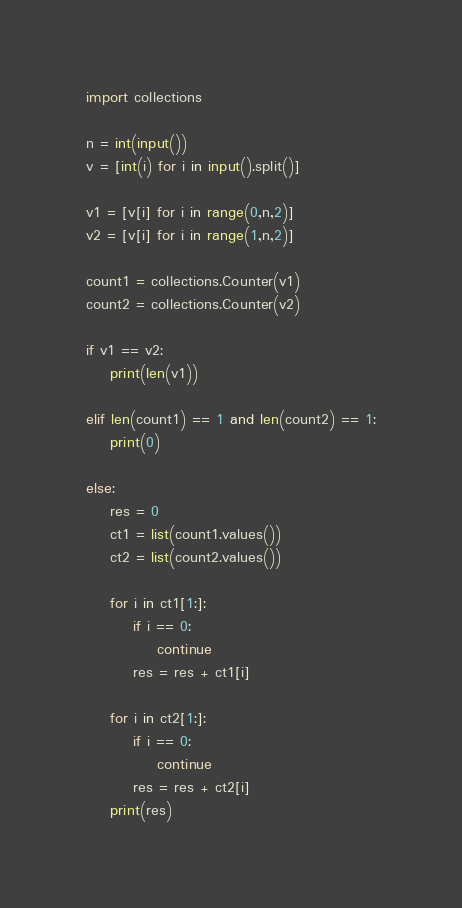<code> <loc_0><loc_0><loc_500><loc_500><_Python_>import collections

n = int(input())
v = [int(i) for i in input().split()]

v1 = [v[i] for i in range(0,n,2)]
v2 = [v[i] for i in range(1,n,2)]

count1 = collections.Counter(v1)
count2 = collections.Counter(v2)

if v1 == v2:
    print(len(v1))

elif len(count1) == 1 and len(count2) == 1:
    print(0)

else:
    res = 0
    ct1 = list(count1.values())
    ct2 = list(count2.values())

    for i in ct1[1:]:
        if i == 0:
            continue
        res = res + ct1[i]

    for i in ct2[1:]:
        if i == 0:
            continue
        res = res + ct2[i]
    print(res)


</code> 